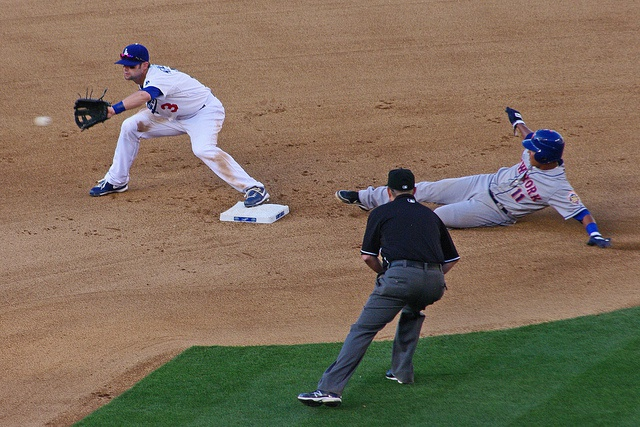Describe the objects in this image and their specific colors. I can see people in tan, black, gray, and blue tones, people in tan, darkgray, and gray tones, people in tan, lavender, darkgray, and gray tones, baseball glove in tan, black, and gray tones, and sports ball in tan, darkgray, lightgray, and gray tones in this image. 